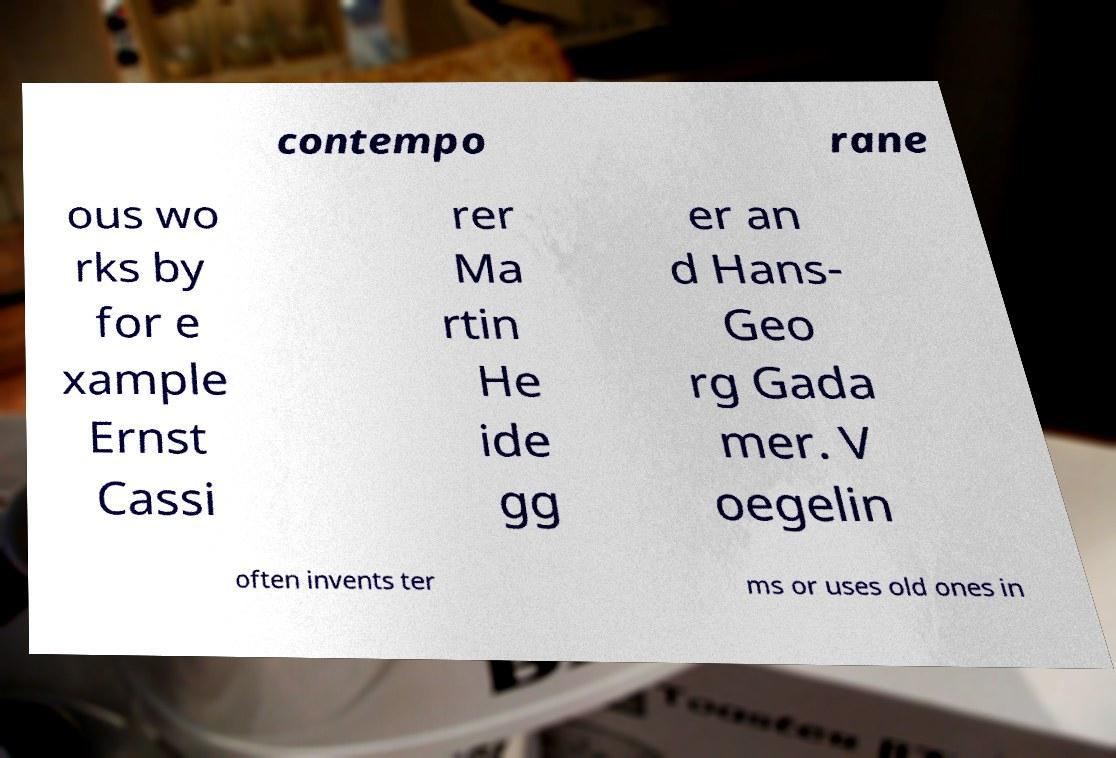Please identify and transcribe the text found in this image. contempo rane ous wo rks by for e xample Ernst Cassi rer Ma rtin He ide gg er an d Hans- Geo rg Gada mer. V oegelin often invents ter ms or uses old ones in 